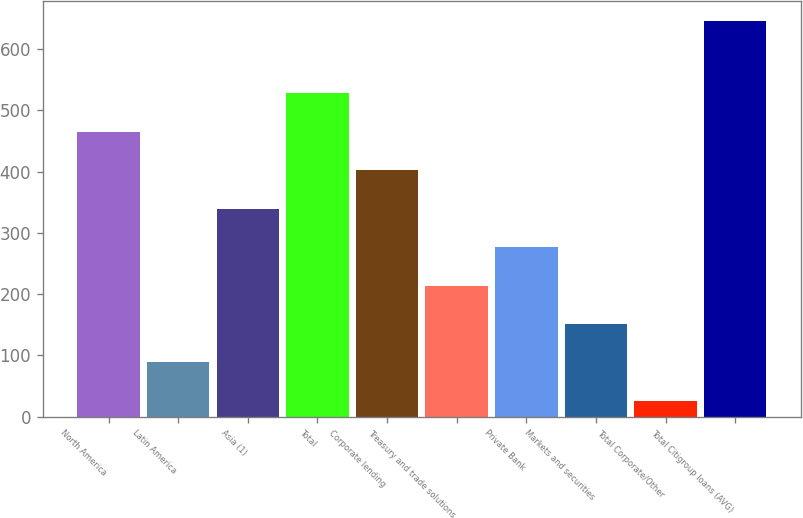Convert chart. <chart><loc_0><loc_0><loc_500><loc_500><bar_chart><fcel>North America<fcel>Latin America<fcel>Asia (1)<fcel>Total<fcel>Corporate lending<fcel>Treasury and trade solutions<fcel>Private Bank<fcel>Markets and securities<fcel>Total Corporate/Other<fcel>Total Citigroup loans (AVG)<nl><fcel>464.98<fcel>88.54<fcel>339.5<fcel>527.72<fcel>402.24<fcel>214.02<fcel>276.76<fcel>151.28<fcel>25.8<fcel>646.3<nl></chart> 